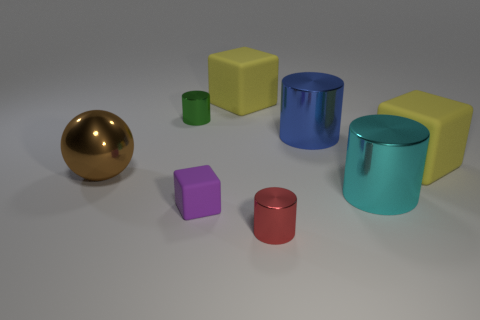Add 1 large metal cylinders. How many objects exist? 9 Subtract all blue cylinders. How many cylinders are left? 3 Subtract all tiny purple blocks. How many blocks are left? 2 Subtract 1 blue cylinders. How many objects are left? 7 Subtract all spheres. How many objects are left? 7 Subtract 2 blocks. How many blocks are left? 1 Subtract all yellow cylinders. Subtract all blue spheres. How many cylinders are left? 4 Subtract all yellow cylinders. How many yellow cubes are left? 2 Subtract all tiny purple matte things. Subtract all big cyan cylinders. How many objects are left? 6 Add 4 purple objects. How many purple objects are left? 5 